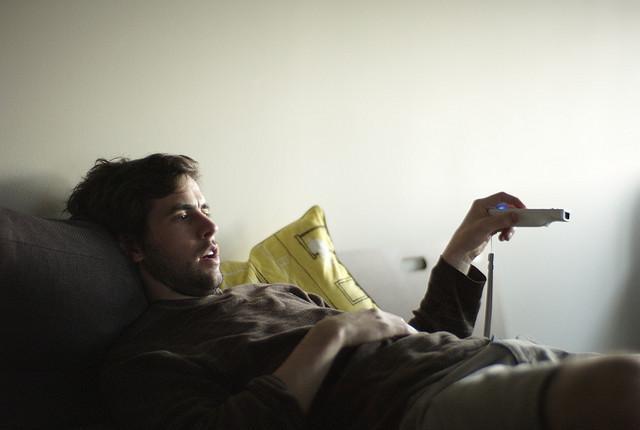How many orange ropescables are attached to the clock?
Give a very brief answer. 0. 